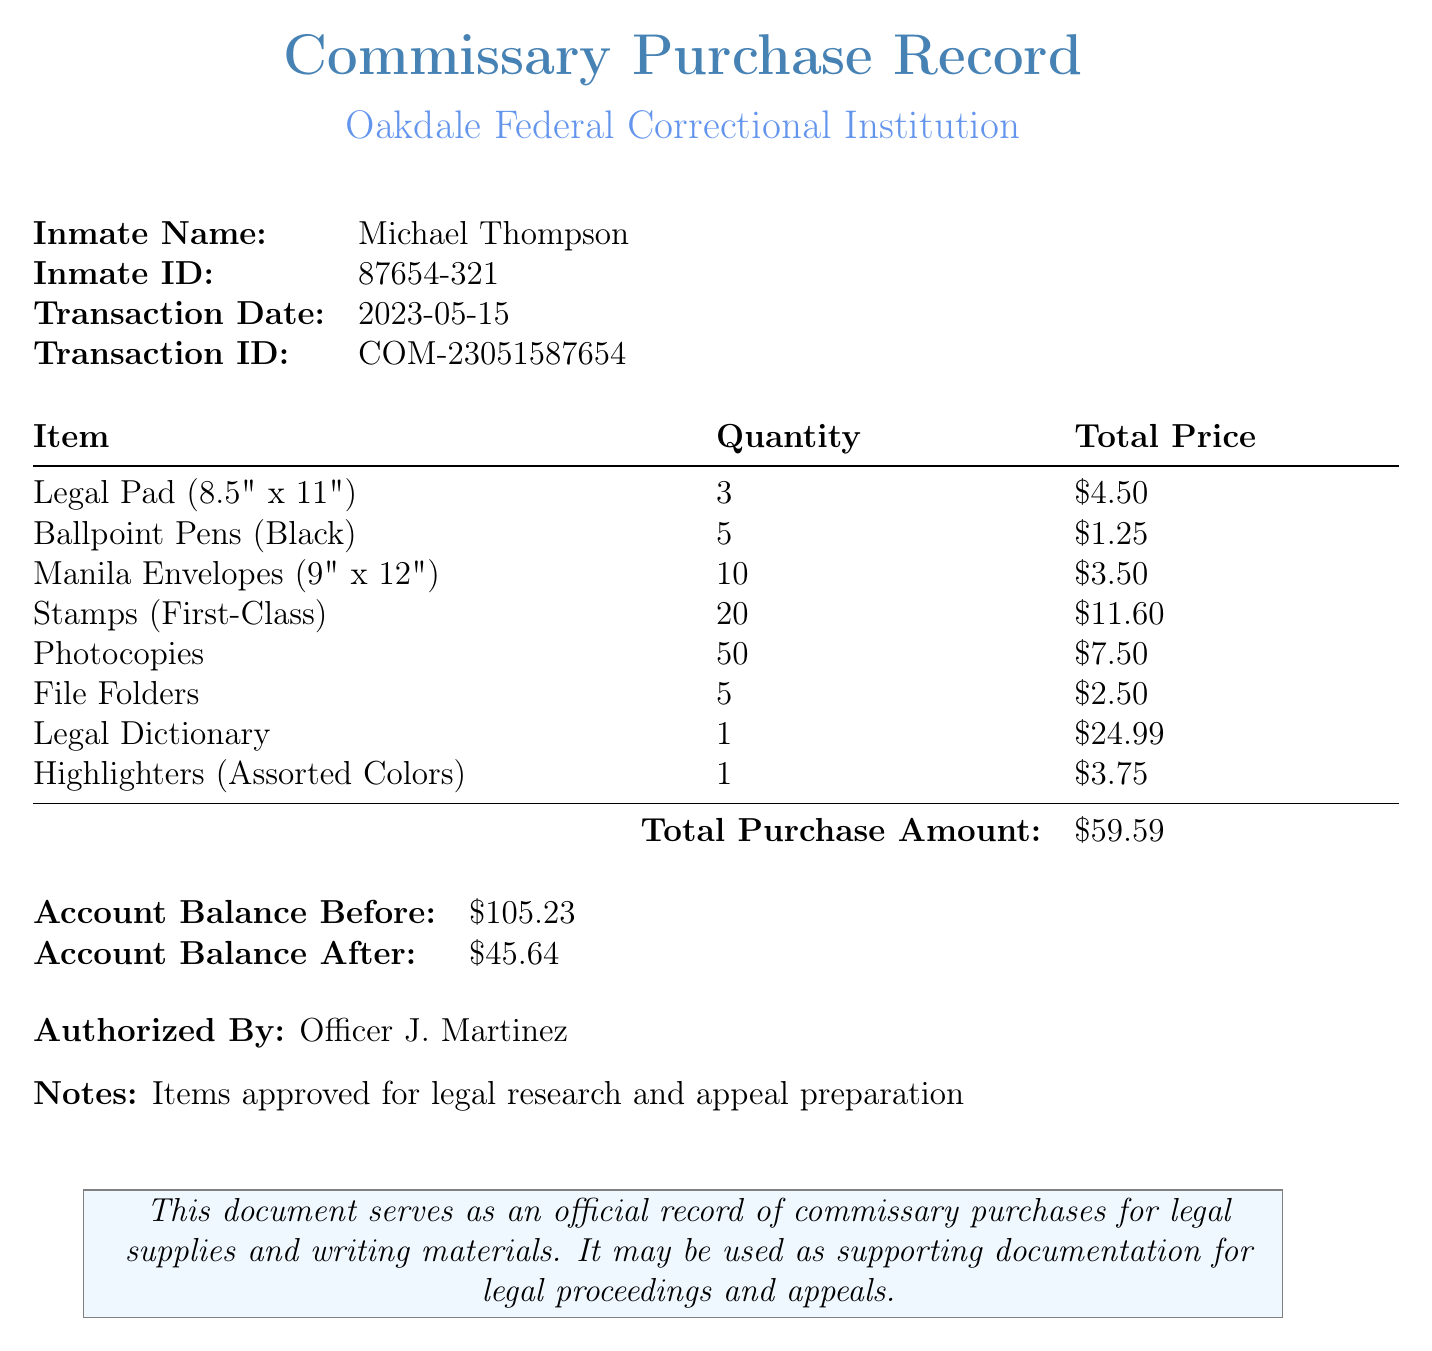What is the name of the inmate? The inmate's name is explicitly mentioned in the document as Michael Thompson.
Answer: Michael Thompson What is the date of the transaction? The date when the transaction took place is specified in the document.
Answer: 2023-05-15 How many Legal Pads were purchased? The number of Legal Pads bought is provided in the item list of the document.
Answer: 3 What is the total purchase amount? The document clearly states the total amount of the transaction.
Answer: $59.59 What was the account balance before the transaction? The document states the account balance prior to the purchase.
Answer: $105.23 How many stamps were purchased? The quantity of stamps bought is indicated in the list of commissary items.
Answer: 20 What is the total price for the Legal Dictionary? The document provides the total price corresponding to the Legal Dictionary.
Answer: $24.99 Who authorized the purchase? The individual who approved the purchase is mentioned in the document.
Answer: Officer J. Martinez What notes are included in the document? Specific notes concerning the purpose of the items are provided in the mention at the end of the document.
Answer: Items approved for legal research and appeal preparation 